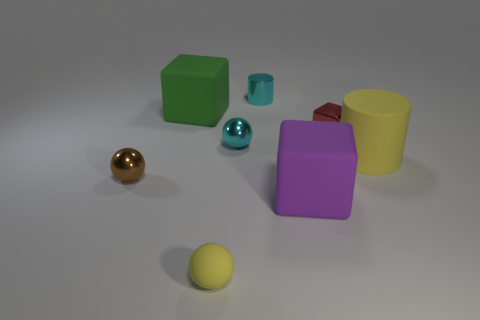There is a object that is in front of the large yellow rubber cylinder and left of the small yellow sphere; what shape is it?
Ensure brevity in your answer.  Sphere. How many big purple things are made of the same material as the yellow sphere?
Keep it short and to the point. 1. What number of small brown metal objects are behind the cylinder to the right of the small shiny cube?
Provide a short and direct response. 0. What shape is the small cyan object behind the ball behind the yellow object to the right of the red shiny object?
Your response must be concise. Cylinder. The rubber ball that is the same color as the large cylinder is what size?
Provide a succinct answer. Small. What number of things are small brown metal things or cyan things?
Provide a succinct answer. 3. What is the color of the other metal ball that is the same size as the cyan shiny ball?
Your answer should be very brief. Brown. Does the tiny matte object have the same shape as the rubber object that is left of the small yellow ball?
Make the answer very short. No. What number of objects are either rubber objects that are in front of the tiny brown shiny sphere or yellow rubber objects that are to the right of the shiny cylinder?
Offer a terse response. 3. There is a thing that is the same color as the matte sphere; what is its shape?
Your answer should be compact. Cylinder. 